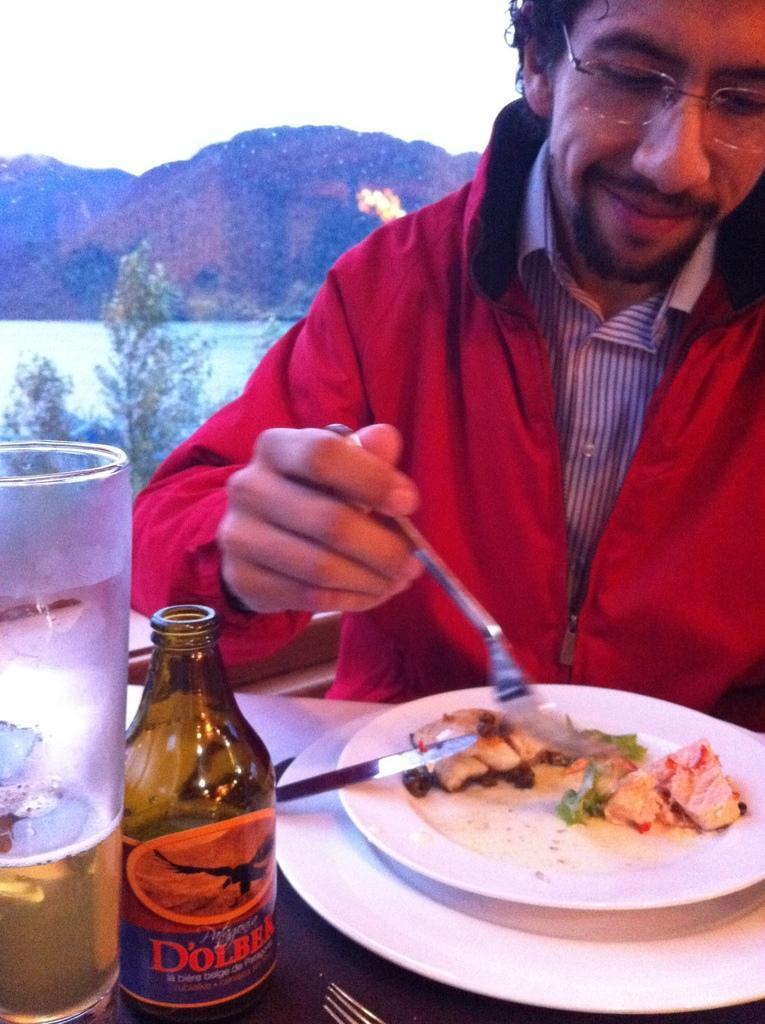Could you give a brief overview of what you see in this image? In the image there is a man eating food on a plate which is on the table and there is a glass in front of him and on back side there is a mountain. 